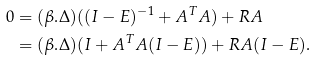Convert formula to latex. <formula><loc_0><loc_0><loc_500><loc_500>0 & = ( \beta . \Delta ) ( ( I - E ) ^ { - 1 } + A ^ { T } A ) + R A \\ & = ( \beta . \Delta ) ( I + A ^ { T } A ( I - E ) ) + R A ( I - E ) .</formula> 